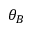<formula> <loc_0><loc_0><loc_500><loc_500>\theta _ { B }</formula> 